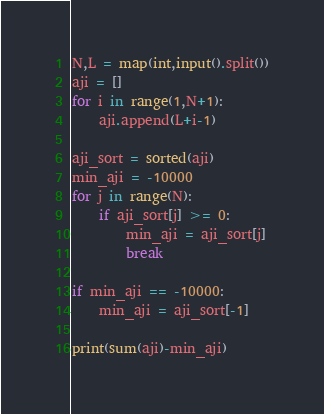<code> <loc_0><loc_0><loc_500><loc_500><_Python_>N,L = map(int,input().split())
aji = []
for i in range(1,N+1):
    aji.append(L+i-1)

aji_sort = sorted(aji)
min_aji = -10000
for j in range(N):
    if aji_sort[j] >= 0:
        min_aji = aji_sort[j]
        break

if min_aji == -10000:
    min_aji = aji_sort[-1]

print(sum(aji)-min_aji)</code> 